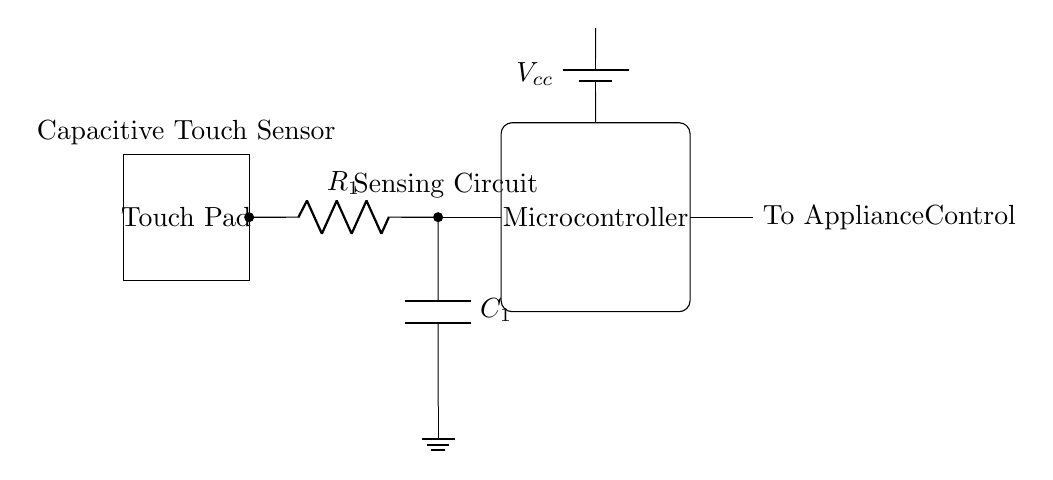What is the primary function of the touch pad? The touch pad serves as the input interface for the capacitive touch sensor, allowing users to interact with the appliance through touch.
Answer: Input interface What component is labeled as R1? R1 is the resistor in the circuit, which is used to limit the current flowing to the capacitor and is essential for determining the sensitivity of the touch sensor.
Answer: Resistor What does C1 represent in the circuit? C1 is the capacitor in the circuit, which is used to store charge and plays a key role in the sensing mechanism by detecting changes in capacitance when the touch pad is activated.
Answer: Capacitor Which part of the circuit processes the input signal? The microcontroller processes the input signal received from the capacitive touch sensor, which interprets the changes in capacitance and determines if the touch event occurred.
Answer: Microcontroller What is the voltage supply for this circuit? The voltage supply for this circuit is denoted as Vcc and typically represents the power source required for the operation of the microcontroller and the sensing circuit.
Answer: Vcc How does the touch sensor detect a touch event? The touch sensor detects a touch event by monitoring changes in capacitance caused by the presence of a finger on the touch pad, which alters the electric field around the sensor, triggering a response from the microcontroller.
Answer: Changes in capacitance What type of circuit is represented in this diagram? The circuit is a capacitive touch sensor circuit designed for user input in modern kitchen appliances, illustrating how touch events are sensed and processed.
Answer: Capacitive touch sensor circuit 